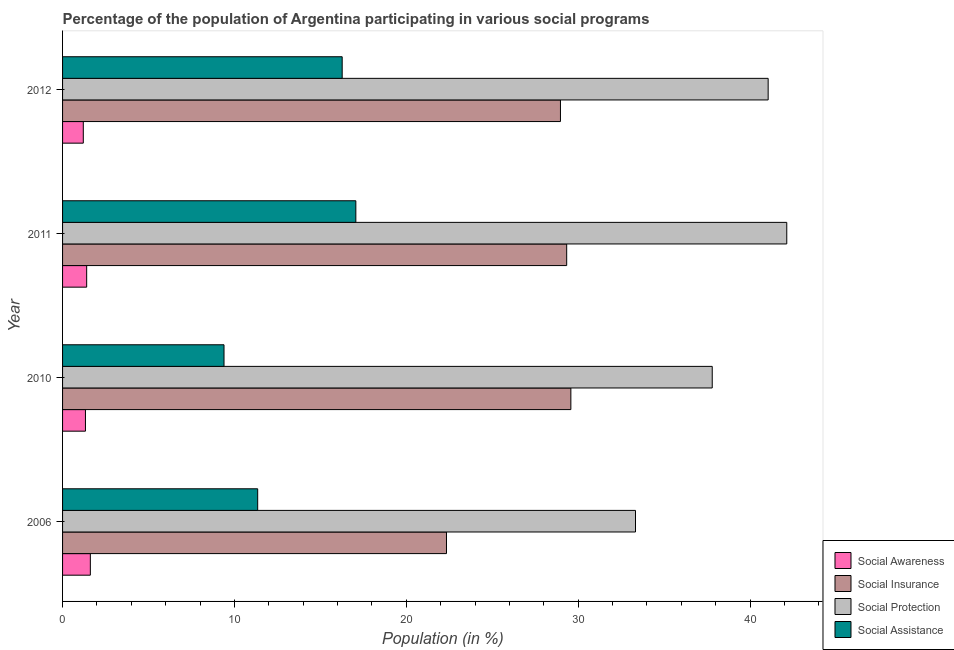Are the number of bars on each tick of the Y-axis equal?
Offer a terse response. Yes. In how many cases, is the number of bars for a given year not equal to the number of legend labels?
Offer a very short reply. 0. What is the participation of population in social protection programs in 2012?
Make the answer very short. 41.05. Across all years, what is the maximum participation of population in social assistance programs?
Provide a succinct answer. 17.06. Across all years, what is the minimum participation of population in social protection programs?
Give a very brief answer. 33.34. What is the total participation of population in social awareness programs in the graph?
Give a very brief answer. 5.56. What is the difference between the participation of population in social awareness programs in 2006 and that in 2010?
Your answer should be very brief. 0.28. What is the difference between the participation of population in social insurance programs in 2006 and the participation of population in social protection programs in 2011?
Your response must be concise. -19.8. What is the average participation of population in social protection programs per year?
Provide a succinct answer. 38.58. In the year 2006, what is the difference between the participation of population in social assistance programs and participation of population in social awareness programs?
Your answer should be compact. 9.74. What is the ratio of the participation of population in social awareness programs in 2010 to that in 2011?
Your answer should be very brief. 0.95. Is the difference between the participation of population in social protection programs in 2010 and 2012 greater than the difference between the participation of population in social insurance programs in 2010 and 2012?
Your answer should be compact. No. What is the difference between the highest and the second highest participation of population in social protection programs?
Provide a short and direct response. 1.08. What is the difference between the highest and the lowest participation of population in social assistance programs?
Ensure brevity in your answer.  7.67. In how many years, is the participation of population in social awareness programs greater than the average participation of population in social awareness programs taken over all years?
Make the answer very short. 2. Is the sum of the participation of population in social insurance programs in 2011 and 2012 greater than the maximum participation of population in social awareness programs across all years?
Give a very brief answer. Yes. Is it the case that in every year, the sum of the participation of population in social awareness programs and participation of population in social insurance programs is greater than the sum of participation of population in social assistance programs and participation of population in social protection programs?
Your answer should be compact. No. What does the 1st bar from the top in 2010 represents?
Your answer should be compact. Social Assistance. What does the 2nd bar from the bottom in 2006 represents?
Your answer should be compact. Social Insurance. How many bars are there?
Keep it short and to the point. 16. Are all the bars in the graph horizontal?
Ensure brevity in your answer.  Yes. Does the graph contain any zero values?
Offer a very short reply. No. Where does the legend appear in the graph?
Offer a very short reply. Bottom right. How are the legend labels stacked?
Provide a succinct answer. Vertical. What is the title of the graph?
Make the answer very short. Percentage of the population of Argentina participating in various social programs . Does "Primary education" appear as one of the legend labels in the graph?
Your answer should be compact. No. What is the label or title of the X-axis?
Your answer should be very brief. Population (in %). What is the label or title of the Y-axis?
Offer a very short reply. Year. What is the Population (in %) in Social Awareness in 2006?
Keep it short and to the point. 1.62. What is the Population (in %) of Social Insurance in 2006?
Offer a very short reply. 22.34. What is the Population (in %) in Social Protection in 2006?
Your answer should be compact. 33.34. What is the Population (in %) of Social Assistance in 2006?
Provide a succinct answer. 11.35. What is the Population (in %) in Social Awareness in 2010?
Keep it short and to the point. 1.33. What is the Population (in %) in Social Insurance in 2010?
Offer a terse response. 29.58. What is the Population (in %) of Social Protection in 2010?
Provide a succinct answer. 37.8. What is the Population (in %) of Social Assistance in 2010?
Your response must be concise. 9.39. What is the Population (in %) of Social Awareness in 2011?
Offer a very short reply. 1.4. What is the Population (in %) of Social Insurance in 2011?
Make the answer very short. 29.33. What is the Population (in %) of Social Protection in 2011?
Provide a short and direct response. 42.14. What is the Population (in %) of Social Assistance in 2011?
Provide a short and direct response. 17.06. What is the Population (in %) in Social Awareness in 2012?
Offer a terse response. 1.21. What is the Population (in %) of Social Insurance in 2012?
Make the answer very short. 28.97. What is the Population (in %) of Social Protection in 2012?
Keep it short and to the point. 41.05. What is the Population (in %) of Social Assistance in 2012?
Offer a very short reply. 16.27. Across all years, what is the maximum Population (in %) of Social Awareness?
Give a very brief answer. 1.62. Across all years, what is the maximum Population (in %) in Social Insurance?
Give a very brief answer. 29.58. Across all years, what is the maximum Population (in %) of Social Protection?
Give a very brief answer. 42.14. Across all years, what is the maximum Population (in %) of Social Assistance?
Offer a terse response. 17.06. Across all years, what is the minimum Population (in %) in Social Awareness?
Offer a very short reply. 1.21. Across all years, what is the minimum Population (in %) of Social Insurance?
Your response must be concise. 22.34. Across all years, what is the minimum Population (in %) of Social Protection?
Your answer should be compact. 33.34. Across all years, what is the minimum Population (in %) in Social Assistance?
Offer a very short reply. 9.39. What is the total Population (in %) of Social Awareness in the graph?
Offer a very short reply. 5.56. What is the total Population (in %) in Social Insurance in the graph?
Your answer should be compact. 110.22. What is the total Population (in %) in Social Protection in the graph?
Give a very brief answer. 154.33. What is the total Population (in %) in Social Assistance in the graph?
Your answer should be very brief. 54.08. What is the difference between the Population (in %) of Social Awareness in 2006 and that in 2010?
Offer a terse response. 0.28. What is the difference between the Population (in %) of Social Insurance in 2006 and that in 2010?
Your response must be concise. -7.24. What is the difference between the Population (in %) of Social Protection in 2006 and that in 2010?
Your response must be concise. -4.47. What is the difference between the Population (in %) in Social Assistance in 2006 and that in 2010?
Give a very brief answer. 1.96. What is the difference between the Population (in %) of Social Awareness in 2006 and that in 2011?
Give a very brief answer. 0.21. What is the difference between the Population (in %) in Social Insurance in 2006 and that in 2011?
Provide a succinct answer. -6.99. What is the difference between the Population (in %) in Social Protection in 2006 and that in 2011?
Offer a terse response. -8.8. What is the difference between the Population (in %) of Social Assistance in 2006 and that in 2011?
Offer a very short reply. -5.71. What is the difference between the Population (in %) of Social Awareness in 2006 and that in 2012?
Offer a terse response. 0.41. What is the difference between the Population (in %) of Social Insurance in 2006 and that in 2012?
Give a very brief answer. -6.63. What is the difference between the Population (in %) in Social Protection in 2006 and that in 2012?
Keep it short and to the point. -7.72. What is the difference between the Population (in %) in Social Assistance in 2006 and that in 2012?
Your response must be concise. -4.92. What is the difference between the Population (in %) in Social Awareness in 2010 and that in 2011?
Your response must be concise. -0.07. What is the difference between the Population (in %) in Social Insurance in 2010 and that in 2011?
Offer a very short reply. 0.24. What is the difference between the Population (in %) in Social Protection in 2010 and that in 2011?
Your answer should be very brief. -4.34. What is the difference between the Population (in %) in Social Assistance in 2010 and that in 2011?
Give a very brief answer. -7.67. What is the difference between the Population (in %) in Social Awareness in 2010 and that in 2012?
Offer a terse response. 0.13. What is the difference between the Population (in %) of Social Insurance in 2010 and that in 2012?
Make the answer very short. 0.61. What is the difference between the Population (in %) in Social Protection in 2010 and that in 2012?
Provide a short and direct response. -3.25. What is the difference between the Population (in %) in Social Assistance in 2010 and that in 2012?
Provide a short and direct response. -6.88. What is the difference between the Population (in %) in Social Awareness in 2011 and that in 2012?
Make the answer very short. 0.2. What is the difference between the Population (in %) in Social Insurance in 2011 and that in 2012?
Offer a terse response. 0.36. What is the difference between the Population (in %) of Social Protection in 2011 and that in 2012?
Give a very brief answer. 1.08. What is the difference between the Population (in %) of Social Assistance in 2011 and that in 2012?
Keep it short and to the point. 0.79. What is the difference between the Population (in %) of Social Awareness in 2006 and the Population (in %) of Social Insurance in 2010?
Your response must be concise. -27.96. What is the difference between the Population (in %) of Social Awareness in 2006 and the Population (in %) of Social Protection in 2010?
Give a very brief answer. -36.18. What is the difference between the Population (in %) of Social Awareness in 2006 and the Population (in %) of Social Assistance in 2010?
Your response must be concise. -7.78. What is the difference between the Population (in %) in Social Insurance in 2006 and the Population (in %) in Social Protection in 2010?
Ensure brevity in your answer.  -15.46. What is the difference between the Population (in %) in Social Insurance in 2006 and the Population (in %) in Social Assistance in 2010?
Offer a terse response. 12.94. What is the difference between the Population (in %) of Social Protection in 2006 and the Population (in %) of Social Assistance in 2010?
Offer a terse response. 23.94. What is the difference between the Population (in %) in Social Awareness in 2006 and the Population (in %) in Social Insurance in 2011?
Provide a succinct answer. -27.72. What is the difference between the Population (in %) in Social Awareness in 2006 and the Population (in %) in Social Protection in 2011?
Provide a succinct answer. -40.52. What is the difference between the Population (in %) in Social Awareness in 2006 and the Population (in %) in Social Assistance in 2011?
Keep it short and to the point. -15.45. What is the difference between the Population (in %) in Social Insurance in 2006 and the Population (in %) in Social Protection in 2011?
Your answer should be very brief. -19.8. What is the difference between the Population (in %) of Social Insurance in 2006 and the Population (in %) of Social Assistance in 2011?
Provide a short and direct response. 5.27. What is the difference between the Population (in %) in Social Protection in 2006 and the Population (in %) in Social Assistance in 2011?
Provide a short and direct response. 16.27. What is the difference between the Population (in %) in Social Awareness in 2006 and the Population (in %) in Social Insurance in 2012?
Offer a terse response. -27.35. What is the difference between the Population (in %) in Social Awareness in 2006 and the Population (in %) in Social Protection in 2012?
Your response must be concise. -39.44. What is the difference between the Population (in %) in Social Awareness in 2006 and the Population (in %) in Social Assistance in 2012?
Keep it short and to the point. -14.65. What is the difference between the Population (in %) in Social Insurance in 2006 and the Population (in %) in Social Protection in 2012?
Give a very brief answer. -18.72. What is the difference between the Population (in %) in Social Insurance in 2006 and the Population (in %) in Social Assistance in 2012?
Ensure brevity in your answer.  6.07. What is the difference between the Population (in %) of Social Protection in 2006 and the Population (in %) of Social Assistance in 2012?
Offer a terse response. 17.07. What is the difference between the Population (in %) of Social Awareness in 2010 and the Population (in %) of Social Insurance in 2011?
Ensure brevity in your answer.  -28. What is the difference between the Population (in %) in Social Awareness in 2010 and the Population (in %) in Social Protection in 2011?
Keep it short and to the point. -40.81. What is the difference between the Population (in %) of Social Awareness in 2010 and the Population (in %) of Social Assistance in 2011?
Keep it short and to the point. -15.73. What is the difference between the Population (in %) in Social Insurance in 2010 and the Population (in %) in Social Protection in 2011?
Ensure brevity in your answer.  -12.56. What is the difference between the Population (in %) of Social Insurance in 2010 and the Population (in %) of Social Assistance in 2011?
Ensure brevity in your answer.  12.51. What is the difference between the Population (in %) in Social Protection in 2010 and the Population (in %) in Social Assistance in 2011?
Make the answer very short. 20.74. What is the difference between the Population (in %) of Social Awareness in 2010 and the Population (in %) of Social Insurance in 2012?
Offer a terse response. -27.64. What is the difference between the Population (in %) in Social Awareness in 2010 and the Population (in %) in Social Protection in 2012?
Offer a very short reply. -39.72. What is the difference between the Population (in %) in Social Awareness in 2010 and the Population (in %) in Social Assistance in 2012?
Provide a succinct answer. -14.94. What is the difference between the Population (in %) of Social Insurance in 2010 and the Population (in %) of Social Protection in 2012?
Keep it short and to the point. -11.48. What is the difference between the Population (in %) of Social Insurance in 2010 and the Population (in %) of Social Assistance in 2012?
Provide a succinct answer. 13.31. What is the difference between the Population (in %) in Social Protection in 2010 and the Population (in %) in Social Assistance in 2012?
Give a very brief answer. 21.53. What is the difference between the Population (in %) in Social Awareness in 2011 and the Population (in %) in Social Insurance in 2012?
Offer a terse response. -27.57. What is the difference between the Population (in %) of Social Awareness in 2011 and the Population (in %) of Social Protection in 2012?
Keep it short and to the point. -39.65. What is the difference between the Population (in %) of Social Awareness in 2011 and the Population (in %) of Social Assistance in 2012?
Ensure brevity in your answer.  -14.87. What is the difference between the Population (in %) of Social Insurance in 2011 and the Population (in %) of Social Protection in 2012?
Make the answer very short. -11.72. What is the difference between the Population (in %) in Social Insurance in 2011 and the Population (in %) in Social Assistance in 2012?
Your response must be concise. 13.06. What is the difference between the Population (in %) in Social Protection in 2011 and the Population (in %) in Social Assistance in 2012?
Your answer should be compact. 25.87. What is the average Population (in %) in Social Awareness per year?
Give a very brief answer. 1.39. What is the average Population (in %) of Social Insurance per year?
Make the answer very short. 27.55. What is the average Population (in %) in Social Protection per year?
Provide a succinct answer. 38.58. What is the average Population (in %) of Social Assistance per year?
Keep it short and to the point. 13.52. In the year 2006, what is the difference between the Population (in %) in Social Awareness and Population (in %) in Social Insurance?
Keep it short and to the point. -20.72. In the year 2006, what is the difference between the Population (in %) in Social Awareness and Population (in %) in Social Protection?
Provide a succinct answer. -31.72. In the year 2006, what is the difference between the Population (in %) in Social Awareness and Population (in %) in Social Assistance?
Provide a succinct answer. -9.74. In the year 2006, what is the difference between the Population (in %) of Social Insurance and Population (in %) of Social Protection?
Your answer should be very brief. -11. In the year 2006, what is the difference between the Population (in %) of Social Insurance and Population (in %) of Social Assistance?
Your answer should be very brief. 10.98. In the year 2006, what is the difference between the Population (in %) of Social Protection and Population (in %) of Social Assistance?
Keep it short and to the point. 21.98. In the year 2010, what is the difference between the Population (in %) in Social Awareness and Population (in %) in Social Insurance?
Make the answer very short. -28.24. In the year 2010, what is the difference between the Population (in %) of Social Awareness and Population (in %) of Social Protection?
Provide a short and direct response. -36.47. In the year 2010, what is the difference between the Population (in %) in Social Awareness and Population (in %) in Social Assistance?
Offer a very short reply. -8.06. In the year 2010, what is the difference between the Population (in %) in Social Insurance and Population (in %) in Social Protection?
Your response must be concise. -8.23. In the year 2010, what is the difference between the Population (in %) in Social Insurance and Population (in %) in Social Assistance?
Provide a succinct answer. 20.18. In the year 2010, what is the difference between the Population (in %) of Social Protection and Population (in %) of Social Assistance?
Give a very brief answer. 28.41. In the year 2011, what is the difference between the Population (in %) of Social Awareness and Population (in %) of Social Insurance?
Keep it short and to the point. -27.93. In the year 2011, what is the difference between the Population (in %) of Social Awareness and Population (in %) of Social Protection?
Offer a very short reply. -40.73. In the year 2011, what is the difference between the Population (in %) in Social Awareness and Population (in %) in Social Assistance?
Make the answer very short. -15.66. In the year 2011, what is the difference between the Population (in %) in Social Insurance and Population (in %) in Social Protection?
Your answer should be compact. -12.81. In the year 2011, what is the difference between the Population (in %) of Social Insurance and Population (in %) of Social Assistance?
Keep it short and to the point. 12.27. In the year 2011, what is the difference between the Population (in %) in Social Protection and Population (in %) in Social Assistance?
Your answer should be compact. 25.07. In the year 2012, what is the difference between the Population (in %) in Social Awareness and Population (in %) in Social Insurance?
Provide a short and direct response. -27.76. In the year 2012, what is the difference between the Population (in %) of Social Awareness and Population (in %) of Social Protection?
Your response must be concise. -39.85. In the year 2012, what is the difference between the Population (in %) in Social Awareness and Population (in %) in Social Assistance?
Your answer should be compact. -15.06. In the year 2012, what is the difference between the Population (in %) in Social Insurance and Population (in %) in Social Protection?
Your answer should be very brief. -12.09. In the year 2012, what is the difference between the Population (in %) of Social Insurance and Population (in %) of Social Assistance?
Keep it short and to the point. 12.7. In the year 2012, what is the difference between the Population (in %) of Social Protection and Population (in %) of Social Assistance?
Provide a short and direct response. 24.79. What is the ratio of the Population (in %) in Social Awareness in 2006 to that in 2010?
Offer a terse response. 1.21. What is the ratio of the Population (in %) in Social Insurance in 2006 to that in 2010?
Your answer should be compact. 0.76. What is the ratio of the Population (in %) in Social Protection in 2006 to that in 2010?
Provide a succinct answer. 0.88. What is the ratio of the Population (in %) of Social Assistance in 2006 to that in 2010?
Keep it short and to the point. 1.21. What is the ratio of the Population (in %) in Social Awareness in 2006 to that in 2011?
Keep it short and to the point. 1.15. What is the ratio of the Population (in %) in Social Insurance in 2006 to that in 2011?
Your answer should be compact. 0.76. What is the ratio of the Population (in %) in Social Protection in 2006 to that in 2011?
Your response must be concise. 0.79. What is the ratio of the Population (in %) in Social Assistance in 2006 to that in 2011?
Ensure brevity in your answer.  0.67. What is the ratio of the Population (in %) in Social Awareness in 2006 to that in 2012?
Provide a succinct answer. 1.34. What is the ratio of the Population (in %) of Social Insurance in 2006 to that in 2012?
Make the answer very short. 0.77. What is the ratio of the Population (in %) in Social Protection in 2006 to that in 2012?
Offer a very short reply. 0.81. What is the ratio of the Population (in %) in Social Assistance in 2006 to that in 2012?
Ensure brevity in your answer.  0.7. What is the ratio of the Population (in %) of Social Awareness in 2010 to that in 2011?
Offer a very short reply. 0.95. What is the ratio of the Population (in %) of Social Insurance in 2010 to that in 2011?
Make the answer very short. 1.01. What is the ratio of the Population (in %) of Social Protection in 2010 to that in 2011?
Keep it short and to the point. 0.9. What is the ratio of the Population (in %) of Social Assistance in 2010 to that in 2011?
Your answer should be very brief. 0.55. What is the ratio of the Population (in %) of Social Awareness in 2010 to that in 2012?
Your answer should be compact. 1.1. What is the ratio of the Population (in %) of Social Insurance in 2010 to that in 2012?
Make the answer very short. 1.02. What is the ratio of the Population (in %) of Social Protection in 2010 to that in 2012?
Keep it short and to the point. 0.92. What is the ratio of the Population (in %) of Social Assistance in 2010 to that in 2012?
Offer a very short reply. 0.58. What is the ratio of the Population (in %) in Social Awareness in 2011 to that in 2012?
Make the answer very short. 1.16. What is the ratio of the Population (in %) of Social Insurance in 2011 to that in 2012?
Ensure brevity in your answer.  1.01. What is the ratio of the Population (in %) of Social Protection in 2011 to that in 2012?
Provide a short and direct response. 1.03. What is the ratio of the Population (in %) of Social Assistance in 2011 to that in 2012?
Ensure brevity in your answer.  1.05. What is the difference between the highest and the second highest Population (in %) of Social Awareness?
Give a very brief answer. 0.21. What is the difference between the highest and the second highest Population (in %) in Social Insurance?
Provide a short and direct response. 0.24. What is the difference between the highest and the second highest Population (in %) in Social Protection?
Offer a terse response. 1.08. What is the difference between the highest and the second highest Population (in %) of Social Assistance?
Offer a terse response. 0.79. What is the difference between the highest and the lowest Population (in %) in Social Awareness?
Your response must be concise. 0.41. What is the difference between the highest and the lowest Population (in %) in Social Insurance?
Make the answer very short. 7.24. What is the difference between the highest and the lowest Population (in %) of Social Protection?
Offer a terse response. 8.8. What is the difference between the highest and the lowest Population (in %) in Social Assistance?
Provide a short and direct response. 7.67. 